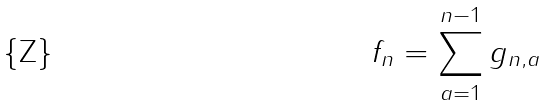<formula> <loc_0><loc_0><loc_500><loc_500>f _ { n } = \sum _ { a = 1 } ^ { n - 1 } g _ { n , a }</formula> 